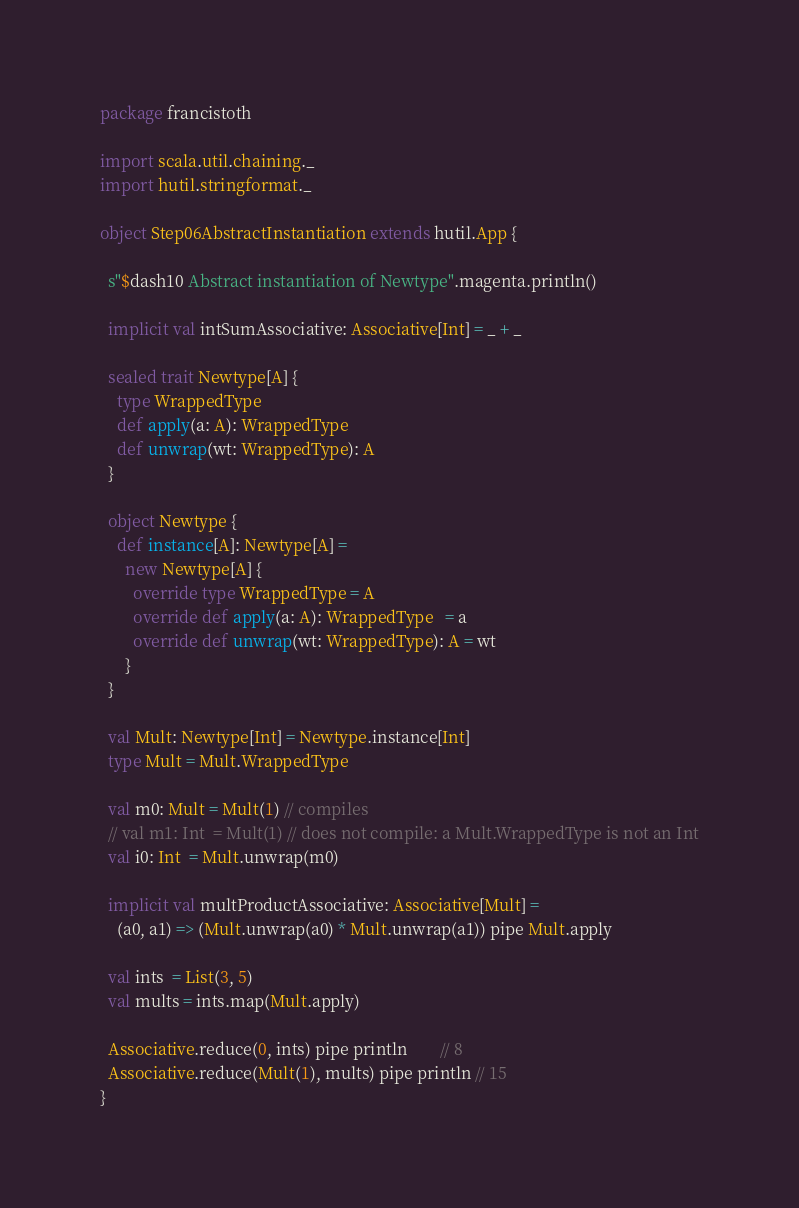Convert code to text. <code><loc_0><loc_0><loc_500><loc_500><_Scala_>package francistoth

import scala.util.chaining._
import hutil.stringformat._

object Step06AbstractInstantiation extends hutil.App {

  s"$dash10 Abstract instantiation of Newtype".magenta.println()

  implicit val intSumAssociative: Associative[Int] = _ + _

  sealed trait Newtype[A] {
    type WrappedType
    def apply(a: A): WrappedType
    def unwrap(wt: WrappedType): A
  }

  object Newtype {
    def instance[A]: Newtype[A] =
      new Newtype[A] {
        override type WrappedType = A
        override def apply(a: A): WrappedType   = a
        override def unwrap(wt: WrappedType): A = wt
      }
  }

  val Mult: Newtype[Int] = Newtype.instance[Int]
  type Mult = Mult.WrappedType

  val m0: Mult = Mult(1) // compiles
  // val m1: Int  = Mult(1) // does not compile: a Mult.WrappedType is not an Int
  val i0: Int  = Mult.unwrap(m0)

  implicit val multProductAssociative: Associative[Mult] =
    (a0, a1) => (Mult.unwrap(a0) * Mult.unwrap(a1)) pipe Mult.apply

  val ints  = List(3, 5)
  val mults = ints.map(Mult.apply)

  Associative.reduce(0, ints) pipe println        // 8
  Associative.reduce(Mult(1), mults) pipe println // 15
}
</code> 